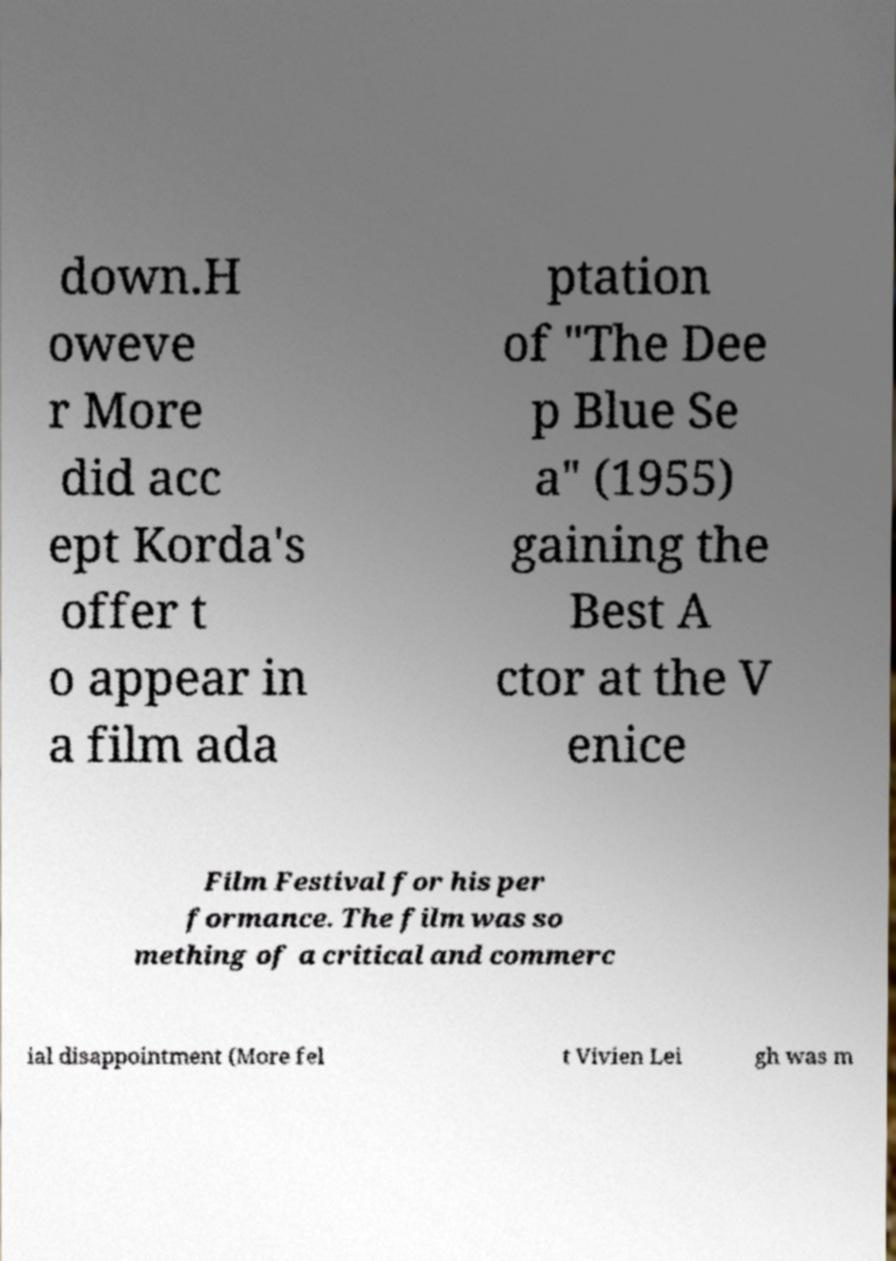Can you accurately transcribe the text from the provided image for me? down.H oweve r More did acc ept Korda's offer t o appear in a film ada ptation of "The Dee p Blue Se a" (1955) gaining the Best A ctor at the V enice Film Festival for his per formance. The film was so mething of a critical and commerc ial disappointment (More fel t Vivien Lei gh was m 